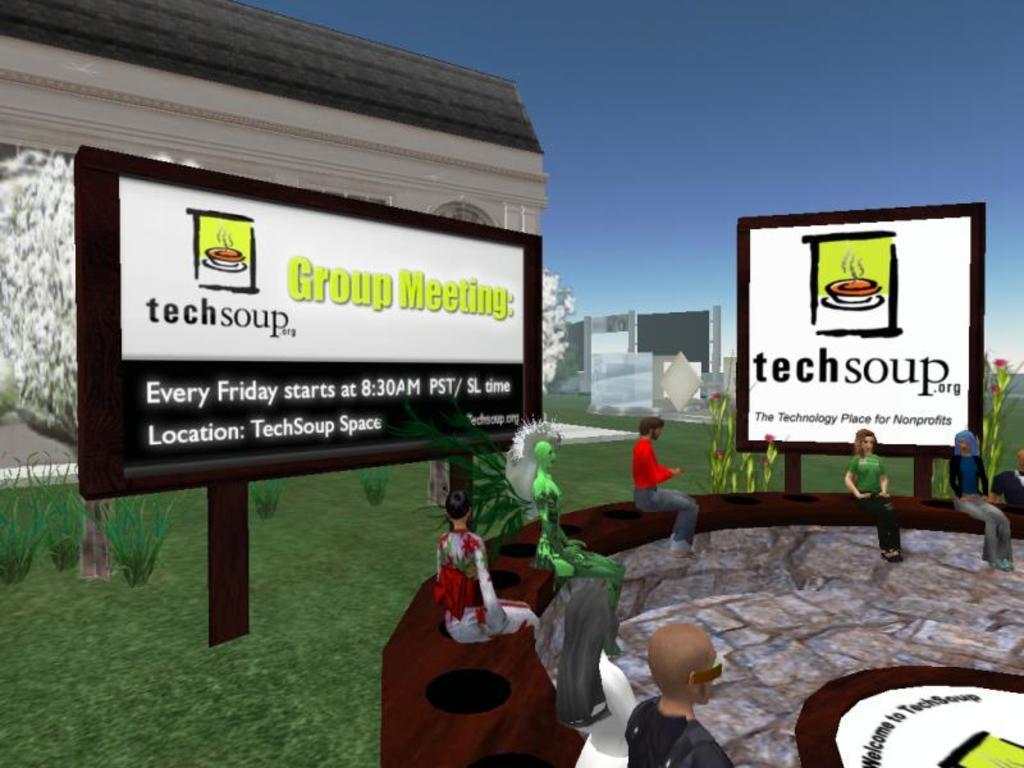Could you give a brief overview of what you see in this image? This is an animated image in this image we can see people, board with some text. In the background of the image there is a building. At the top of the image there is sky. At the bottom of the image there is grass. 